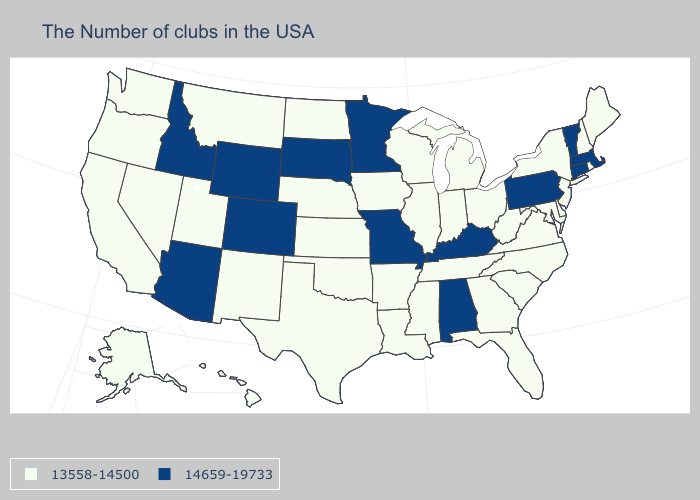Which states have the lowest value in the USA?
Concise answer only. Maine, Rhode Island, New Hampshire, New York, New Jersey, Delaware, Maryland, Virginia, North Carolina, South Carolina, West Virginia, Ohio, Florida, Georgia, Michigan, Indiana, Tennessee, Wisconsin, Illinois, Mississippi, Louisiana, Arkansas, Iowa, Kansas, Nebraska, Oklahoma, Texas, North Dakota, New Mexico, Utah, Montana, Nevada, California, Washington, Oregon, Alaska, Hawaii. Name the states that have a value in the range 13558-14500?
Quick response, please. Maine, Rhode Island, New Hampshire, New York, New Jersey, Delaware, Maryland, Virginia, North Carolina, South Carolina, West Virginia, Ohio, Florida, Georgia, Michigan, Indiana, Tennessee, Wisconsin, Illinois, Mississippi, Louisiana, Arkansas, Iowa, Kansas, Nebraska, Oklahoma, Texas, North Dakota, New Mexico, Utah, Montana, Nevada, California, Washington, Oregon, Alaska, Hawaii. What is the lowest value in states that border Kentucky?
Keep it brief. 13558-14500. What is the value of Maine?
Be succinct. 13558-14500. Among the states that border New Mexico , which have the lowest value?
Write a very short answer. Oklahoma, Texas, Utah. What is the highest value in the USA?
Short answer required. 14659-19733. Name the states that have a value in the range 13558-14500?
Quick response, please. Maine, Rhode Island, New Hampshire, New York, New Jersey, Delaware, Maryland, Virginia, North Carolina, South Carolina, West Virginia, Ohio, Florida, Georgia, Michigan, Indiana, Tennessee, Wisconsin, Illinois, Mississippi, Louisiana, Arkansas, Iowa, Kansas, Nebraska, Oklahoma, Texas, North Dakota, New Mexico, Utah, Montana, Nevada, California, Washington, Oregon, Alaska, Hawaii. What is the value of Hawaii?
Concise answer only. 13558-14500. What is the highest value in the West ?
Answer briefly. 14659-19733. Name the states that have a value in the range 14659-19733?
Be succinct. Massachusetts, Vermont, Connecticut, Pennsylvania, Kentucky, Alabama, Missouri, Minnesota, South Dakota, Wyoming, Colorado, Arizona, Idaho. Does Idaho have the lowest value in the USA?
Answer briefly. No. What is the highest value in the West ?
Be succinct. 14659-19733. Does Vermont have the highest value in the USA?
Answer briefly. Yes. Name the states that have a value in the range 13558-14500?
Concise answer only. Maine, Rhode Island, New Hampshire, New York, New Jersey, Delaware, Maryland, Virginia, North Carolina, South Carolina, West Virginia, Ohio, Florida, Georgia, Michigan, Indiana, Tennessee, Wisconsin, Illinois, Mississippi, Louisiana, Arkansas, Iowa, Kansas, Nebraska, Oklahoma, Texas, North Dakota, New Mexico, Utah, Montana, Nevada, California, Washington, Oregon, Alaska, Hawaii. Name the states that have a value in the range 14659-19733?
Short answer required. Massachusetts, Vermont, Connecticut, Pennsylvania, Kentucky, Alabama, Missouri, Minnesota, South Dakota, Wyoming, Colorado, Arizona, Idaho. 